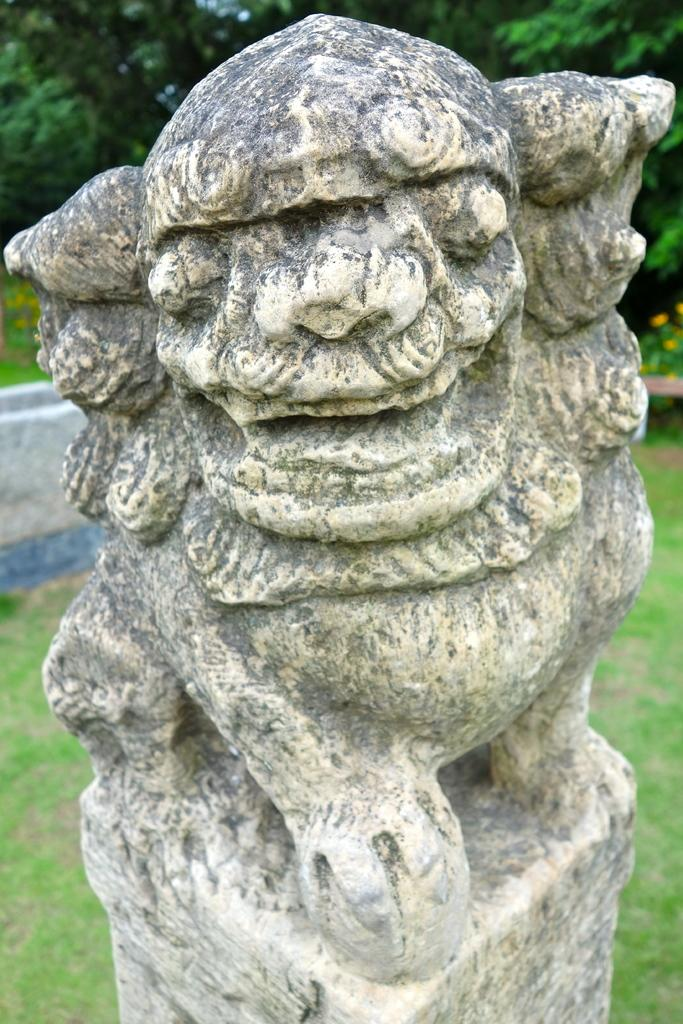What is the main subject in the image? There is a statue in the image. Can you describe the statue's appearance? The statue is in cream color. What can be seen in the background of the image? There are yellow flowers in the background of the image. What type of vegetation is present in the image? There is grass and trees in the image. What is the color of the sky in the image? The sky is in white color. What type of calendar is hanging on the tree in the image? There is no calendar present in the image; it features a statue, yellow flowers, grass, trees, and a white sky. What kind of meal is being prepared in the image? There is no meal preparation visible in the image; it focuses on a statue and its surroundings. 